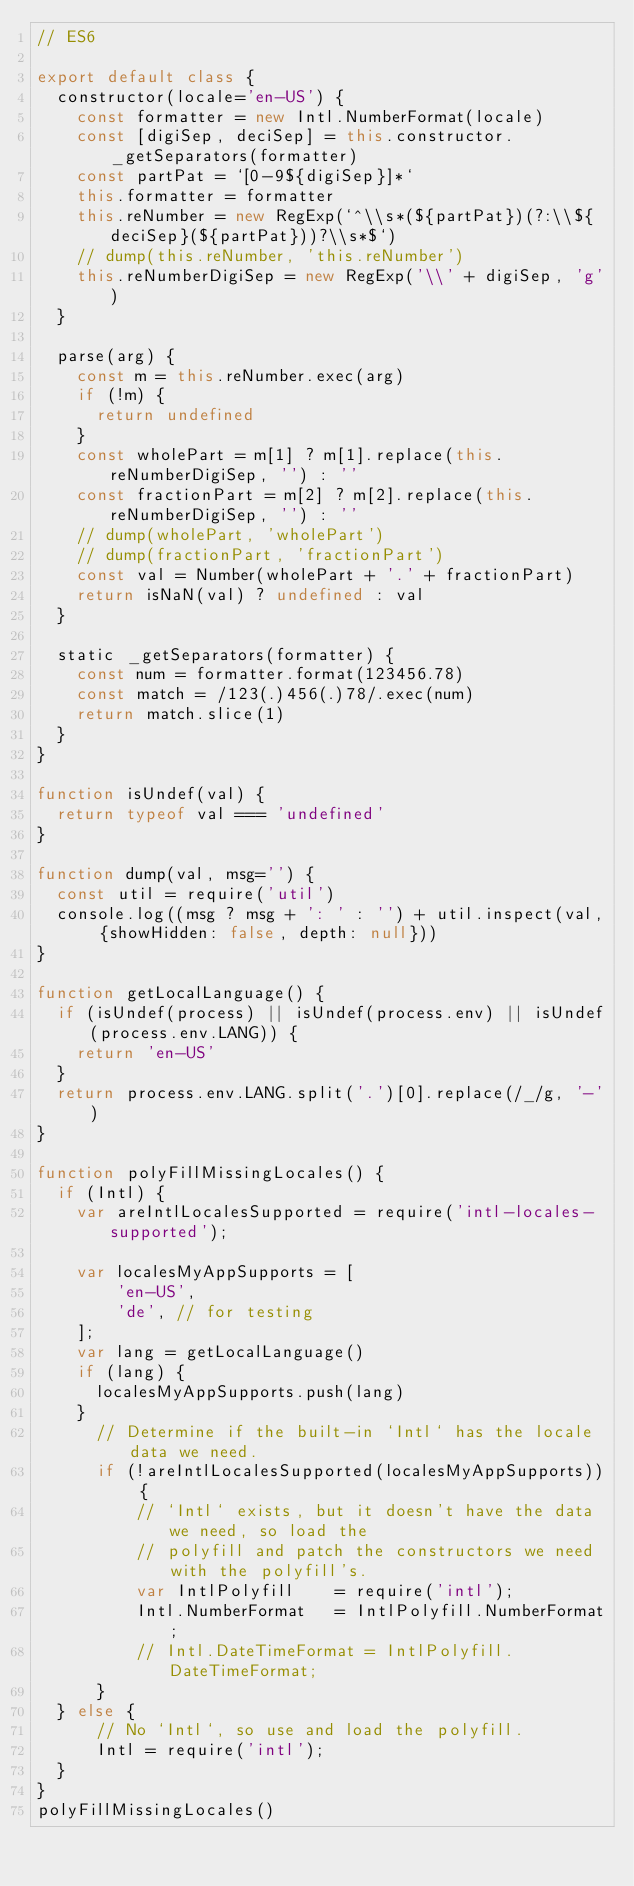Convert code to text. <code><loc_0><loc_0><loc_500><loc_500><_JavaScript_>// ES6

export default class {
	constructor(locale='en-US') {
		const formatter = new Intl.NumberFormat(locale)
		const [digiSep, deciSep] = this.constructor._getSeparators(formatter)
		const partPat = `[0-9${digiSep}]*`
		this.formatter = formatter
		this.reNumber = new RegExp(`^\\s*(${partPat})(?:\\${deciSep}(${partPat}))?\\s*$`)
		// dump(this.reNumber, 'this.reNumber')
		this.reNumberDigiSep = new RegExp('\\' + digiSep, 'g')
	}

	parse(arg) {
		const m = this.reNumber.exec(arg)
		if (!m) {
			return undefined
		}
		const wholePart = m[1] ? m[1].replace(this.reNumberDigiSep, '') : ''
		const fractionPart = m[2] ? m[2].replace(this.reNumberDigiSep, '') : ''
		// dump(wholePart, 'wholePart')
		// dump(fractionPart, 'fractionPart')
		const val = Number(wholePart + '.' + fractionPart)
		return isNaN(val) ? undefined : val
	}

	static _getSeparators(formatter) {
		const num = formatter.format(123456.78)
		const match = /123(.)456(.)78/.exec(num)
		return match.slice(1)
	}
}

function isUndef(val) {
	return typeof val === 'undefined'
}

function dump(val, msg='') {
	const util = require('util')
	console.log((msg ? msg + ': ' : '') + util.inspect(val, {showHidden: false, depth: null}))
}

function getLocalLanguage() {
	if (isUndef(process) || isUndef(process.env) || isUndef(process.env.LANG)) {
		return 'en-US'
	}
	return process.env.LANG.split('.')[0].replace(/_/g, '-')
}

function polyFillMissingLocales() {
	if (Intl) {
		var areIntlLocalesSupported = require('intl-locales-supported');

		var localesMyAppSupports = [
		    'en-US',
		    'de', // for testing
		];
		var lang = getLocalLanguage()
		if (lang) {
			localesMyAppSupports.push(lang)
		}
	    // Determine if the built-in `Intl` has the locale data we need.
	    if (!areIntlLocalesSupported(localesMyAppSupports)) {
	        // `Intl` exists, but it doesn't have the data we need, so load the
	        // polyfill and patch the constructors we need with the polyfill's.
	        var IntlPolyfill    = require('intl');
	        Intl.NumberFormat   = IntlPolyfill.NumberFormat;
	        // Intl.DateTimeFormat = IntlPolyfill.DateTimeFormat;
	    }
	} else {
	    // No `Intl`, so use and load the polyfill.
	    Intl = require('intl');
	}
}
polyFillMissingLocales()</code> 